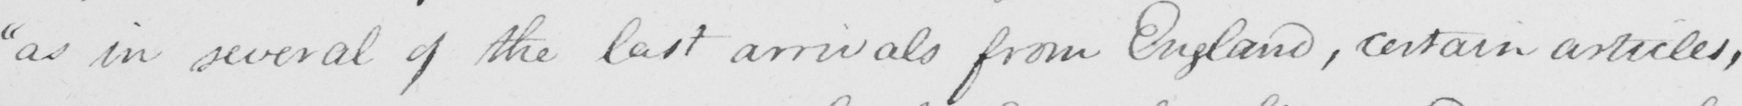What does this handwritten line say? " as in several of the last arrivals from England , certain articles , 